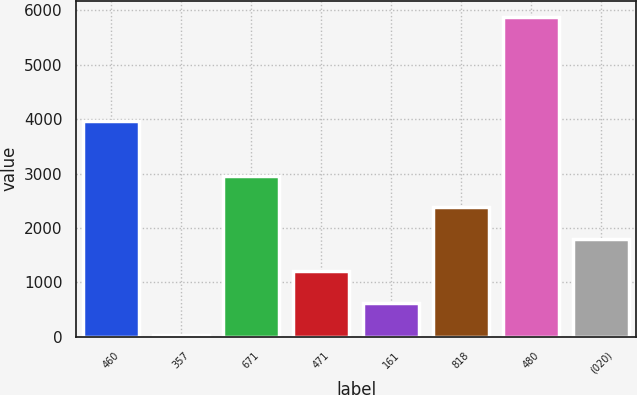Convert chart. <chart><loc_0><loc_0><loc_500><loc_500><bar_chart><fcel>460<fcel>357<fcel>671<fcel>471<fcel>161<fcel>818<fcel>480<fcel>(020)<nl><fcel>3975<fcel>40<fcel>2961.5<fcel>1208.6<fcel>624.3<fcel>2377.2<fcel>5883<fcel>1792.9<nl></chart> 